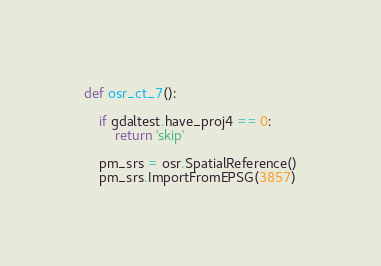<code> <loc_0><loc_0><loc_500><loc_500><_Python_>

def osr_ct_7():

    if gdaltest.have_proj4 == 0:
        return 'skip'

    pm_srs = osr.SpatialReference()
    pm_srs.ImportFromEPSG(3857)
</code> 